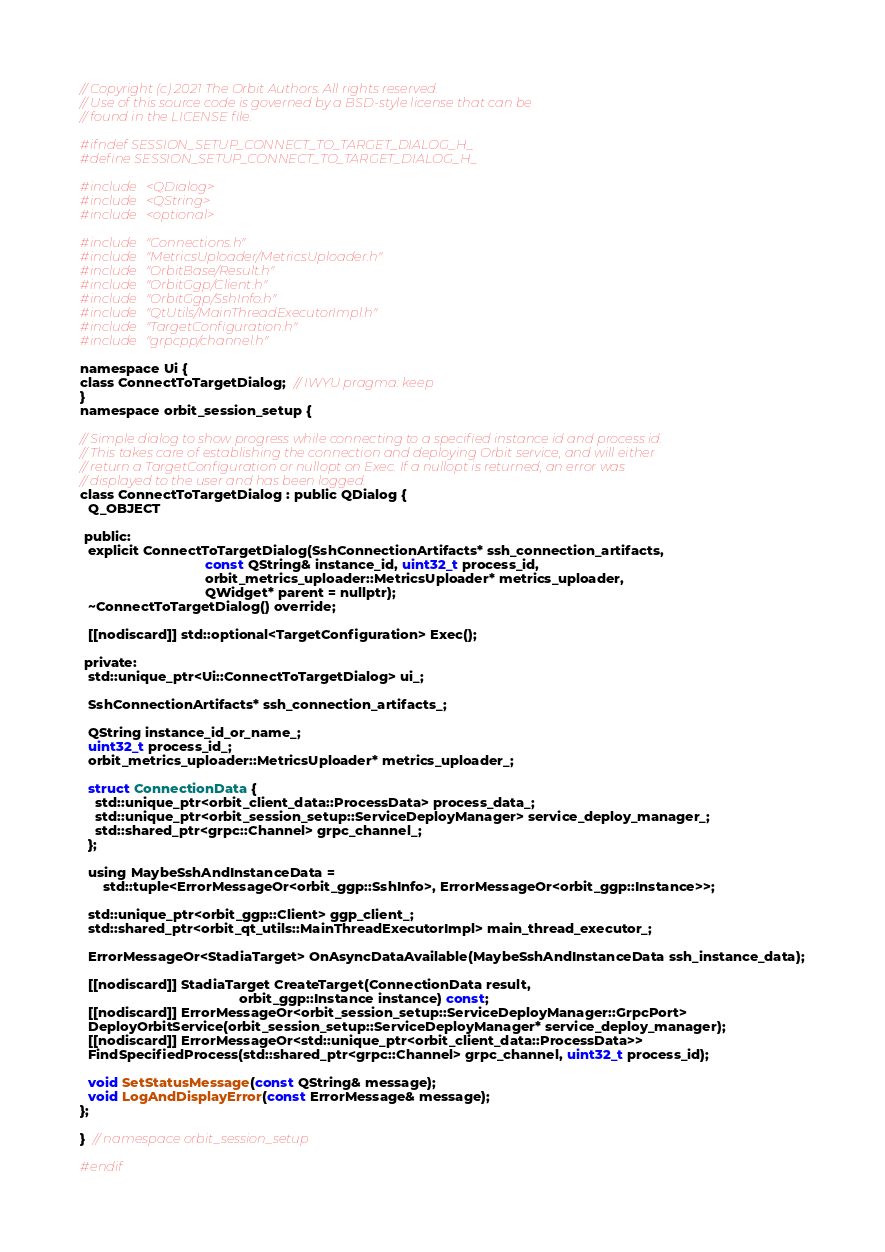Convert code to text. <code><loc_0><loc_0><loc_500><loc_500><_C_>// Copyright (c) 2021 The Orbit Authors. All rights reserved.
// Use of this source code is governed by a BSD-style license that can be
// found in the LICENSE file.

#ifndef SESSION_SETUP_CONNECT_TO_TARGET_DIALOG_H_
#define SESSION_SETUP_CONNECT_TO_TARGET_DIALOG_H_

#include <QDialog>
#include <QString>
#include <optional>

#include "Connections.h"
#include "MetricsUploader/MetricsUploader.h"
#include "OrbitBase/Result.h"
#include "OrbitGgp/Client.h"
#include "OrbitGgp/SshInfo.h"
#include "QtUtils/MainThreadExecutorImpl.h"
#include "TargetConfiguration.h"
#include "grpcpp/channel.h"

namespace Ui {
class ConnectToTargetDialog;  // IWYU pragma: keep
}
namespace orbit_session_setup {

// Simple dialog to show progress while connecting to a specified instance id and process id.
// This takes care of establishing the connection and deploying Orbit service, and will either
// return a TargetConfiguration or nullopt on Exec. If a nullopt is returned, an error was
// displayed to the user and has been logged.
class ConnectToTargetDialog : public QDialog {
  Q_OBJECT

 public:
  explicit ConnectToTargetDialog(SshConnectionArtifacts* ssh_connection_artifacts,
                                 const QString& instance_id, uint32_t process_id,
                                 orbit_metrics_uploader::MetricsUploader* metrics_uploader,
                                 QWidget* parent = nullptr);
  ~ConnectToTargetDialog() override;

  [[nodiscard]] std::optional<TargetConfiguration> Exec();

 private:
  std::unique_ptr<Ui::ConnectToTargetDialog> ui_;

  SshConnectionArtifacts* ssh_connection_artifacts_;

  QString instance_id_or_name_;
  uint32_t process_id_;
  orbit_metrics_uploader::MetricsUploader* metrics_uploader_;

  struct ConnectionData {
    std::unique_ptr<orbit_client_data::ProcessData> process_data_;
    std::unique_ptr<orbit_session_setup::ServiceDeployManager> service_deploy_manager_;
    std::shared_ptr<grpc::Channel> grpc_channel_;
  };

  using MaybeSshAndInstanceData =
      std::tuple<ErrorMessageOr<orbit_ggp::SshInfo>, ErrorMessageOr<orbit_ggp::Instance>>;

  std::unique_ptr<orbit_ggp::Client> ggp_client_;
  std::shared_ptr<orbit_qt_utils::MainThreadExecutorImpl> main_thread_executor_;

  ErrorMessageOr<StadiaTarget> OnAsyncDataAvailable(MaybeSshAndInstanceData ssh_instance_data);

  [[nodiscard]] StadiaTarget CreateTarget(ConnectionData result,
                                          orbit_ggp::Instance instance) const;
  [[nodiscard]] ErrorMessageOr<orbit_session_setup::ServiceDeployManager::GrpcPort>
  DeployOrbitService(orbit_session_setup::ServiceDeployManager* service_deploy_manager);
  [[nodiscard]] ErrorMessageOr<std::unique_ptr<orbit_client_data::ProcessData>>
  FindSpecifiedProcess(std::shared_ptr<grpc::Channel> grpc_channel, uint32_t process_id);

  void SetStatusMessage(const QString& message);
  void LogAndDisplayError(const ErrorMessage& message);
};

}  // namespace orbit_session_setup

#endif</code> 